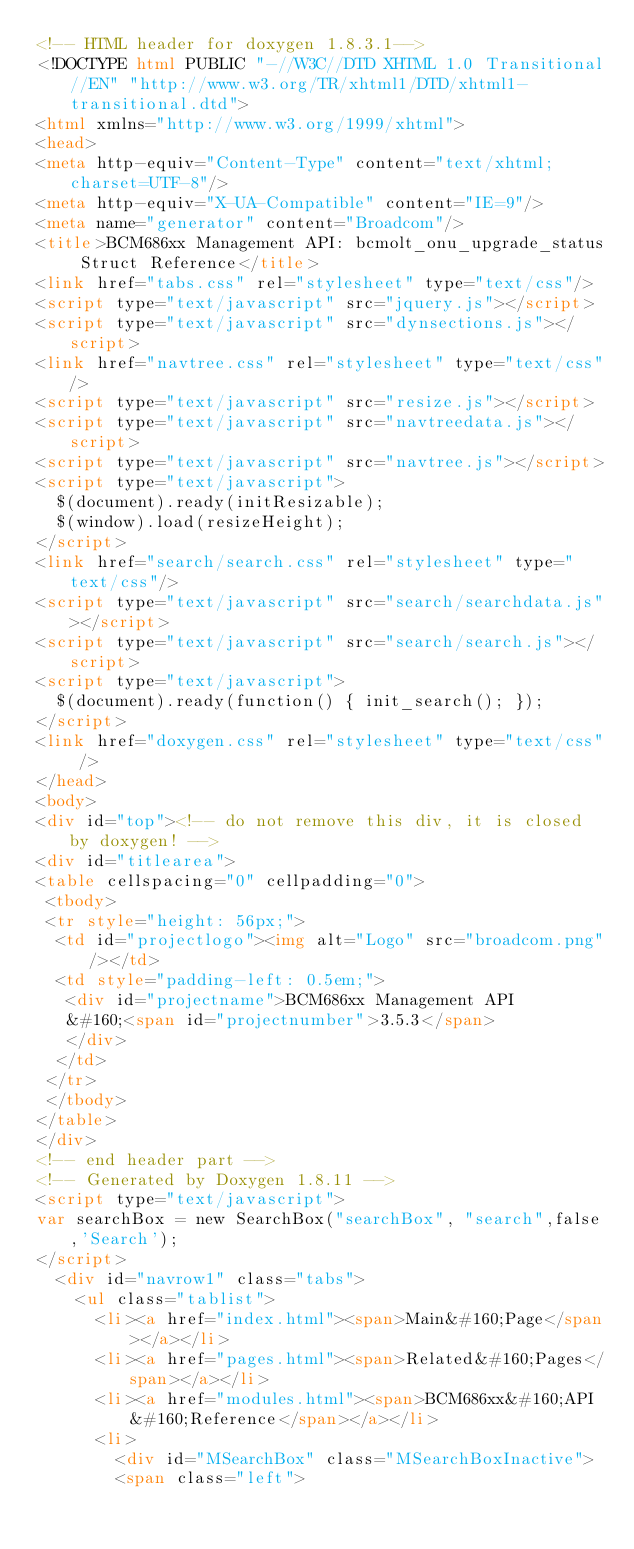Convert code to text. <code><loc_0><loc_0><loc_500><loc_500><_HTML_><!-- HTML header for doxygen 1.8.3.1-->
<!DOCTYPE html PUBLIC "-//W3C//DTD XHTML 1.0 Transitional//EN" "http://www.w3.org/TR/xhtml1/DTD/xhtml1-transitional.dtd">
<html xmlns="http://www.w3.org/1999/xhtml">
<head>
<meta http-equiv="Content-Type" content="text/xhtml;charset=UTF-8"/>
<meta http-equiv="X-UA-Compatible" content="IE=9"/>
<meta name="generator" content="Broadcom"/>
<title>BCM686xx Management API: bcmolt_onu_upgrade_status Struct Reference</title>
<link href="tabs.css" rel="stylesheet" type="text/css"/>
<script type="text/javascript" src="jquery.js"></script>
<script type="text/javascript" src="dynsections.js"></script>
<link href="navtree.css" rel="stylesheet" type="text/css"/>
<script type="text/javascript" src="resize.js"></script>
<script type="text/javascript" src="navtreedata.js"></script>
<script type="text/javascript" src="navtree.js"></script>
<script type="text/javascript">
  $(document).ready(initResizable);
  $(window).load(resizeHeight);
</script>
<link href="search/search.css" rel="stylesheet" type="text/css"/>
<script type="text/javascript" src="search/searchdata.js"></script>
<script type="text/javascript" src="search/search.js"></script>
<script type="text/javascript">
  $(document).ready(function() { init_search(); });
</script>
<link href="doxygen.css" rel="stylesheet" type="text/css" />
</head>
<body>
<div id="top"><!-- do not remove this div, it is closed by doxygen! -->
<div id="titlearea">
<table cellspacing="0" cellpadding="0">
 <tbody>
 <tr style="height: 56px;">
  <td id="projectlogo"><img alt="Logo" src="broadcom.png"/></td>
  <td style="padding-left: 0.5em;">
   <div id="projectname">BCM686xx Management API
   &#160;<span id="projectnumber">3.5.3</span>
   </div>
  </td>
 </tr>
 </tbody>
</table>
</div>
<!-- end header part -->
<!-- Generated by Doxygen 1.8.11 -->
<script type="text/javascript">
var searchBox = new SearchBox("searchBox", "search",false,'Search');
</script>
  <div id="navrow1" class="tabs">
    <ul class="tablist">
      <li><a href="index.html"><span>Main&#160;Page</span></a></li>
      <li><a href="pages.html"><span>Related&#160;Pages</span></a></li>
      <li><a href="modules.html"><span>BCM686xx&#160;API&#160;Reference</span></a></li>
      <li>
        <div id="MSearchBox" class="MSearchBoxInactive">
        <span class="left"></code> 